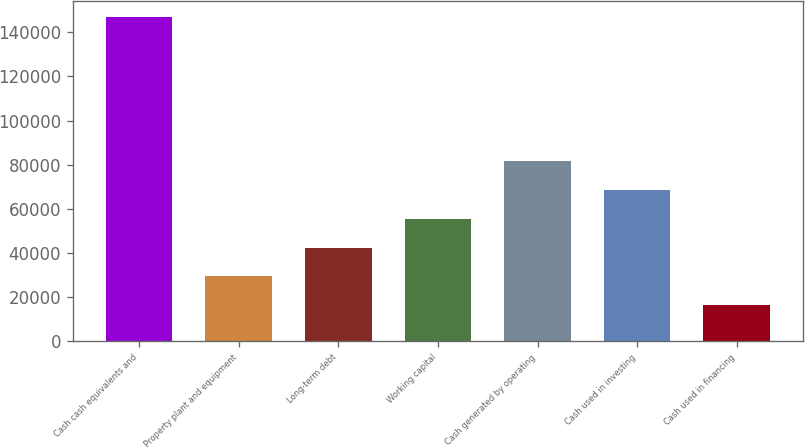Convert chart. <chart><loc_0><loc_0><loc_500><loc_500><bar_chart><fcel>Cash cash equivalents and<fcel>Property plant and equipment<fcel>Long-term debt<fcel>Working capital<fcel>Cash generated by operating<fcel>Cash used in investing<fcel>Cash used in financing<nl><fcel>146761<fcel>29417.2<fcel>42455.4<fcel>55493.6<fcel>81570<fcel>68531.8<fcel>16379<nl></chart> 